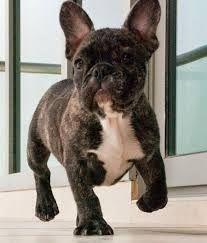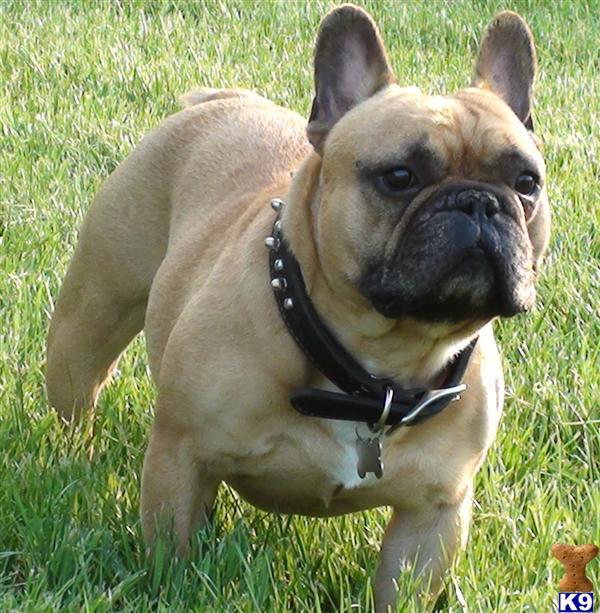The first image is the image on the left, the second image is the image on the right. Examine the images to the left and right. Is the description "One dog has its tongue out." accurate? Answer yes or no. No. The first image is the image on the left, the second image is the image on the right. For the images displayed, is the sentence "In one of the images a dog is wearing an object." factually correct? Answer yes or no. Yes. 